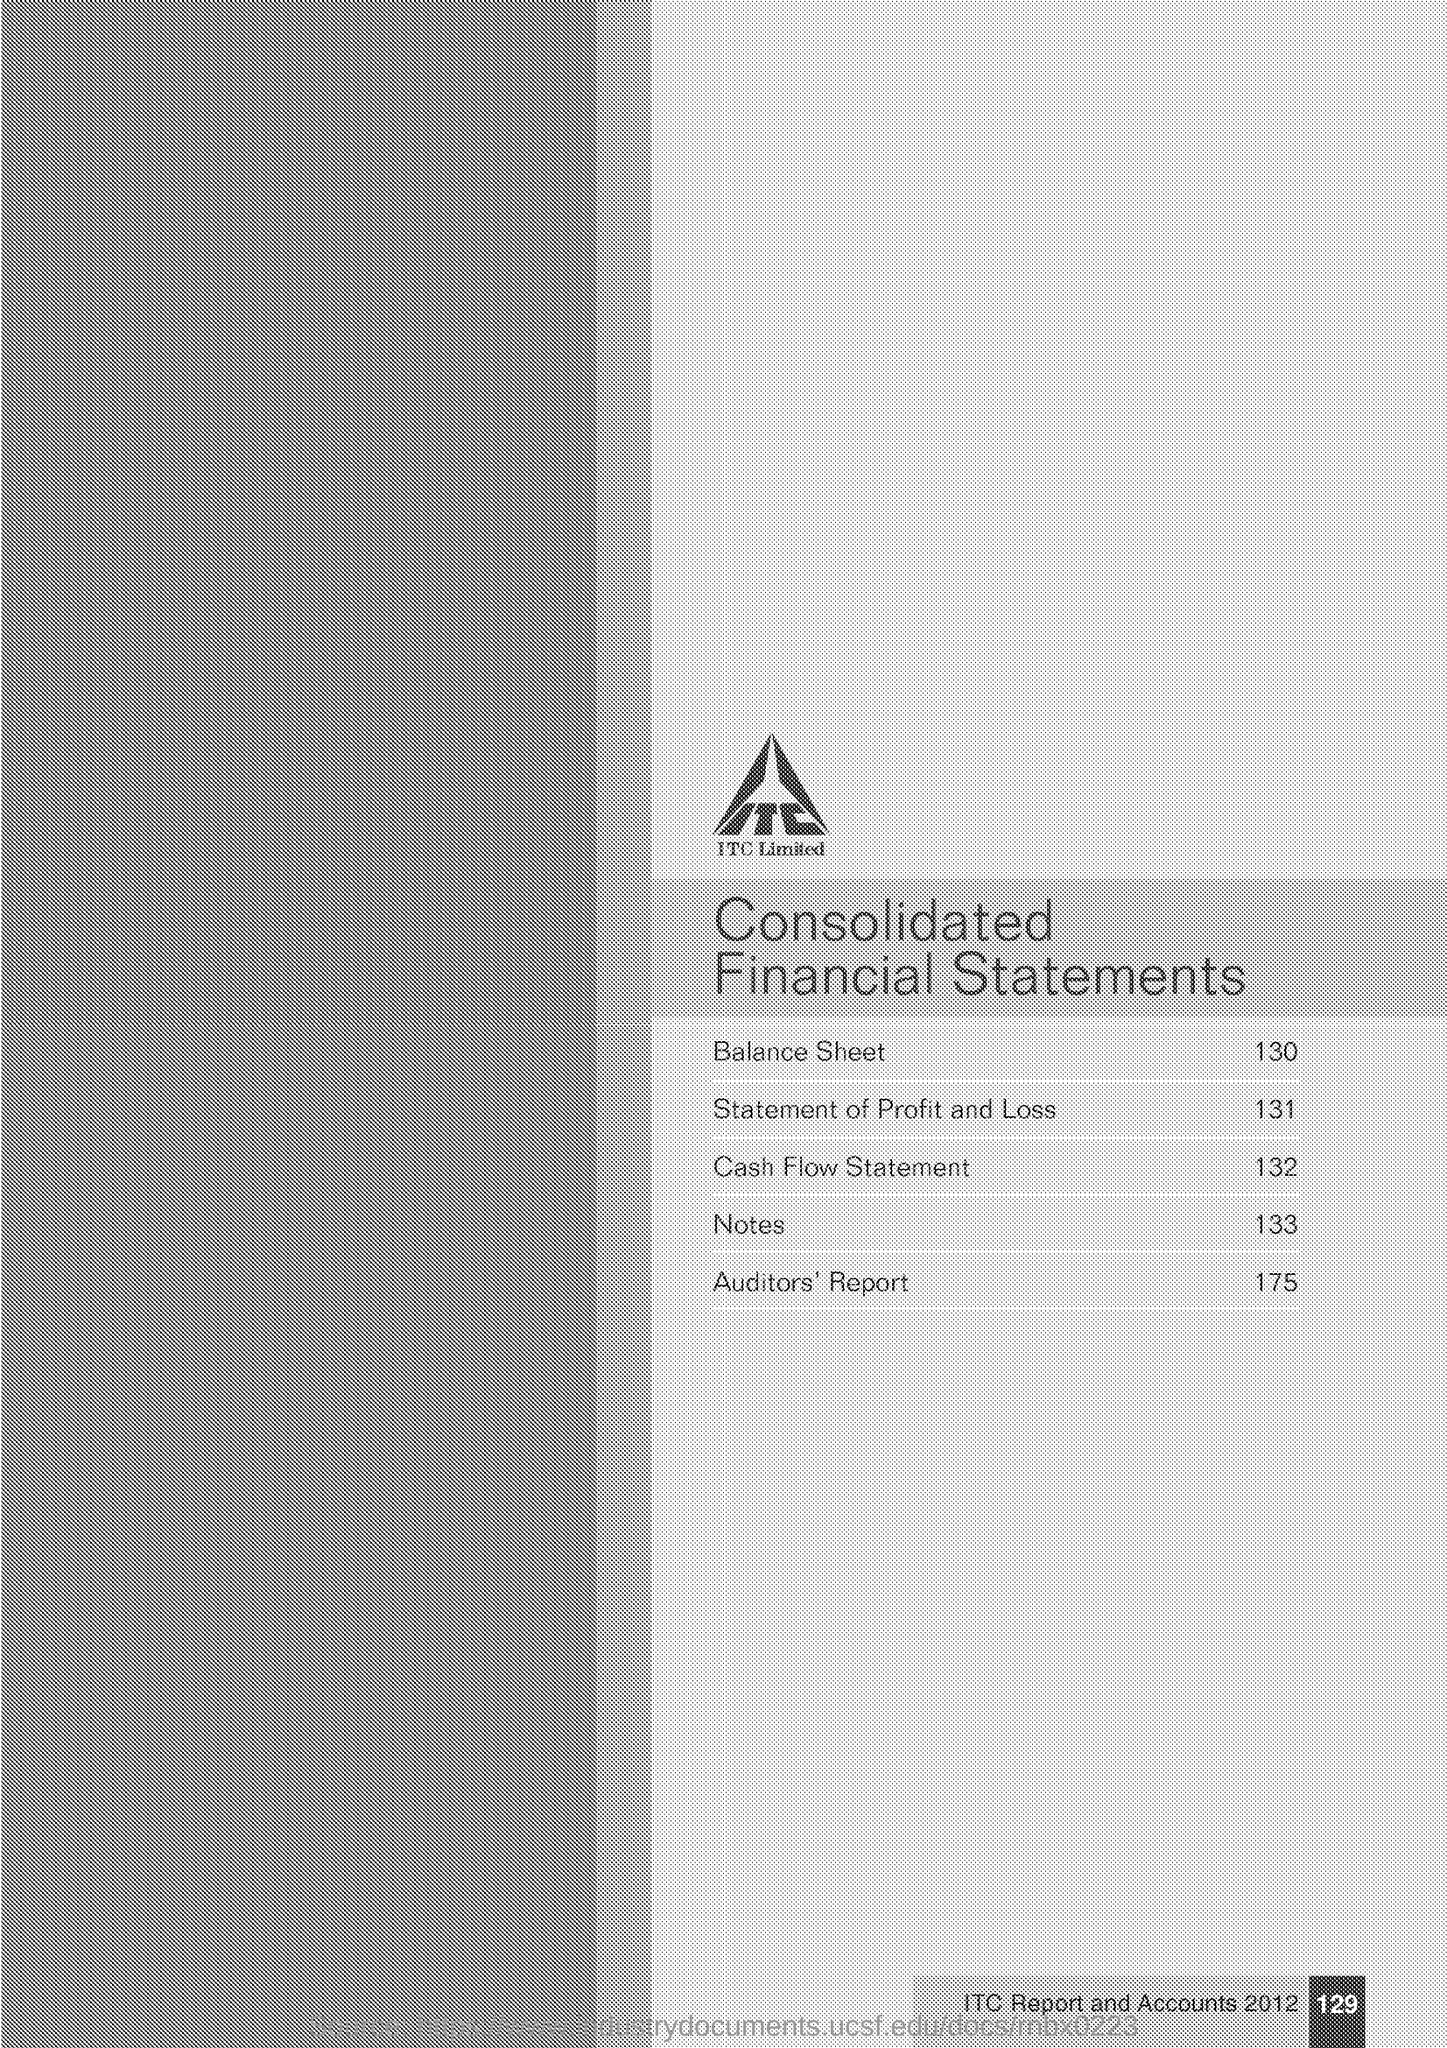What is the page number of the document?
Make the answer very short. 129. What is the page no: of "Balance Sheet" ?
Your answer should be very brief. 130. What is the page no: of "Profit and Loss" ?
Offer a very short reply. 131. What is the page no: of "Cash flow statement" ?
Your answer should be very brief. 132. What is the page no: of "Notes" ?
Keep it short and to the point. 133. What is the page no: of "Auditors Report" ?
Provide a succinct answer. 175. 